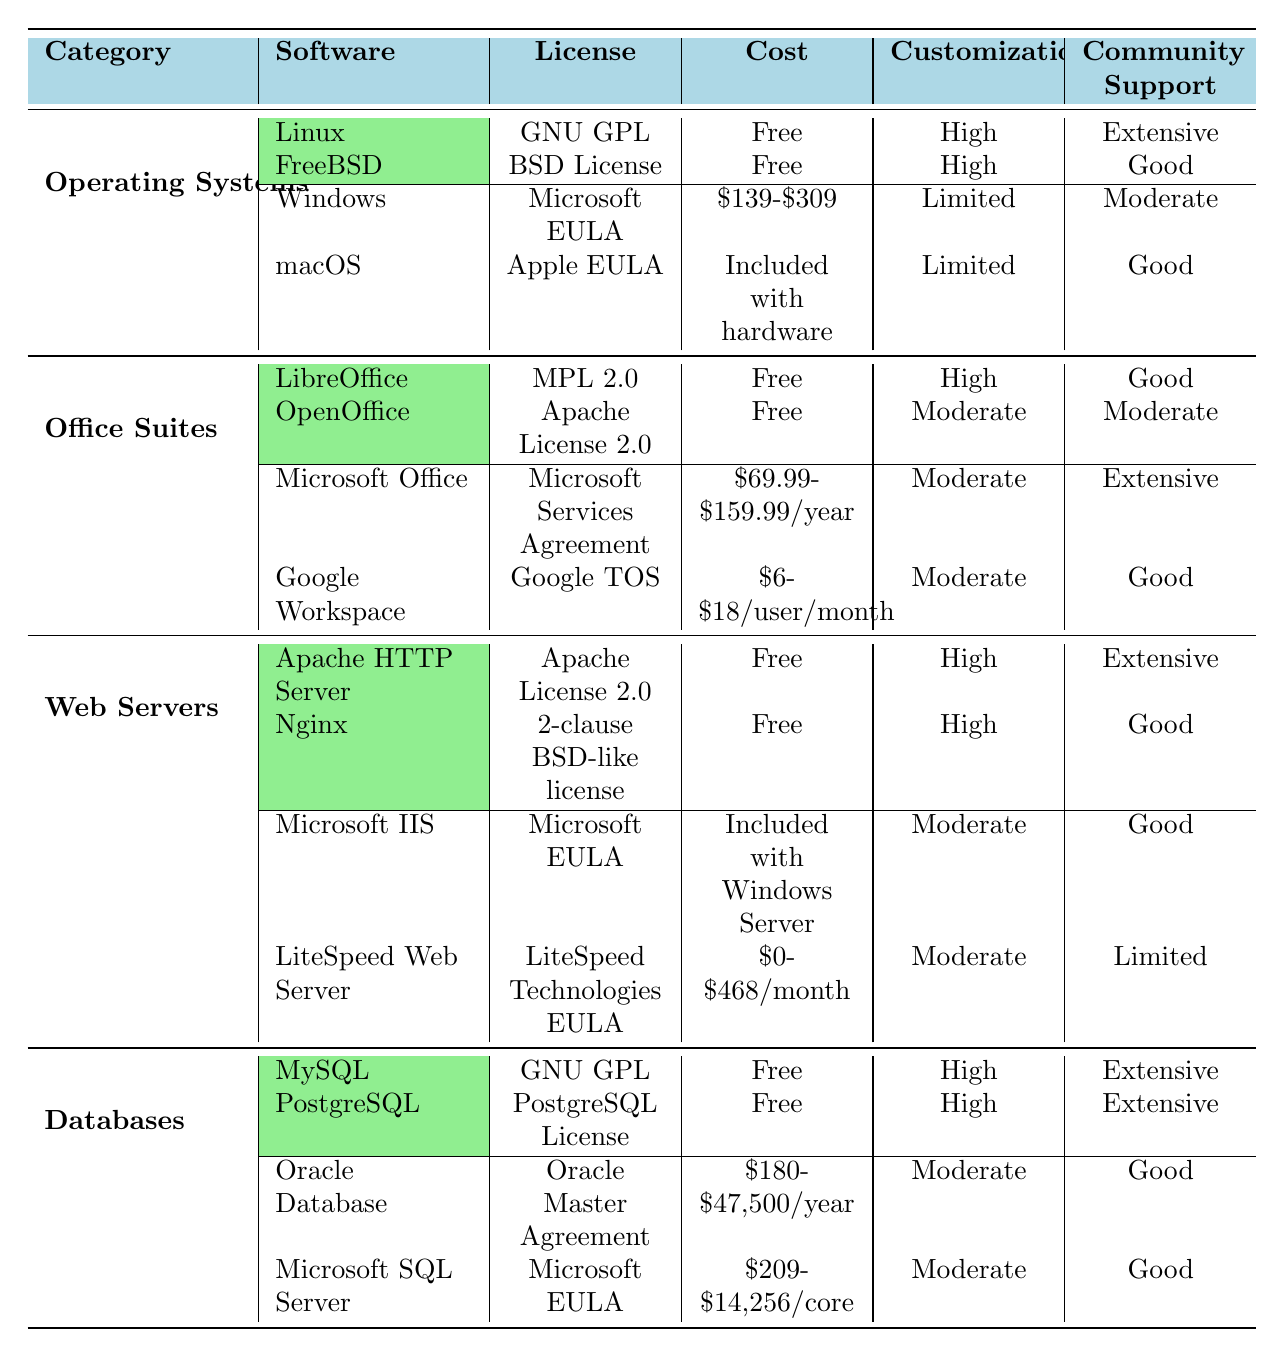What is the cost of Microsoft Office? The table indicates that the cost of Microsoft Office is between $69.99 and $159.99 per year.
Answer: $69.99-$159.99/year Which open-source operating system has extensive community support? Both Linux and FreeBSD listed as open-source operating systems have extensive and good community support, respectively. Specifically, Linux is noted for extensive community support.
Answer: Linux Is the customization level for macOS limited or high? The customization level for macOS listed in the table is described as limited.
Answer: Limited Which software under the Office Suites category has free cost? Both LibreOffice and OpenOffice are labeled as free in the cost column under the Office Suites category.
Answer: LibreOffice and OpenOffice What is the total range of cost for proprietary databases? The cost ranges from $180 to $47,500 for Oracle Database and from $209 to $14,256 for Microsoft SQL Server. To find the total cost range, we take the lowest (180) and the highest (47500) values across both.
Answer: $180-$47,500 How many web servers are mentioned, and which has a high level of customization? There are two open-source web servers listed, Apache HTTP Server and Nginx, both characterized by high customization. The proprietary web servers mentioned are Microsoft IIS and LiteSpeed Web Server.
Answer: 2 open-source web servers with high customization Is the community support for Oracle Database moderate or extensive? The table specifies that the community support for Oracle Database is rated as good, which is considered moderate.
Answer: Moderate Which software has the highest customization option among the open-source databases? Both MySQL and PostgreSQL have high customization options as indicated in the table.
Answer: MySQL and PostgreSQL Are there any proprietary office suites with extensive community support? The table shows that Microsoft Office has extensive community support, while Google Workspace has good community support, thus it can be concluded that Microsoft Office is the only office suite with extensive support.
Answer: Yes Which category has the highest number of entries in the provided data? By counting the entries, the operating systems, office suites, web servers, and databases each have four entries. Therefore, all categories have the same count.
Answer: All categories have the same number of entries (4) 